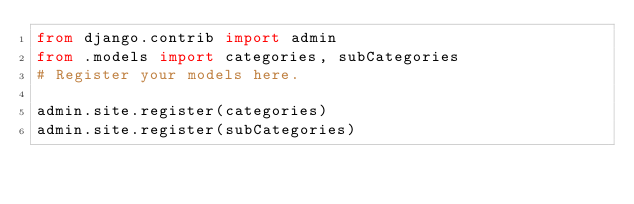<code> <loc_0><loc_0><loc_500><loc_500><_Python_>from django.contrib import admin
from .models import categories, subCategories
# Register your models here.

admin.site.register(categories)
admin.site.register(subCategories)


</code> 